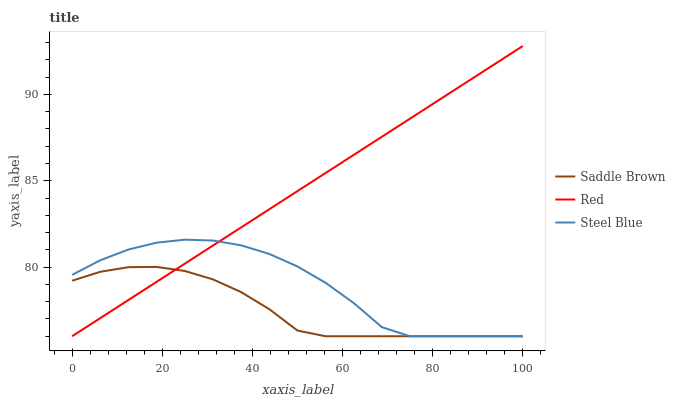Does Saddle Brown have the minimum area under the curve?
Answer yes or no. Yes. Does Red have the maximum area under the curve?
Answer yes or no. Yes. Does Steel Blue have the minimum area under the curve?
Answer yes or no. No. Does Steel Blue have the maximum area under the curve?
Answer yes or no. No. Is Red the smoothest?
Answer yes or no. Yes. Is Steel Blue the roughest?
Answer yes or no. Yes. Is Steel Blue the smoothest?
Answer yes or no. No. Is Red the roughest?
Answer yes or no. No. Does Saddle Brown have the lowest value?
Answer yes or no. Yes. Does Red have the highest value?
Answer yes or no. Yes. Does Steel Blue have the highest value?
Answer yes or no. No. Does Red intersect Steel Blue?
Answer yes or no. Yes. Is Red less than Steel Blue?
Answer yes or no. No. Is Red greater than Steel Blue?
Answer yes or no. No. 